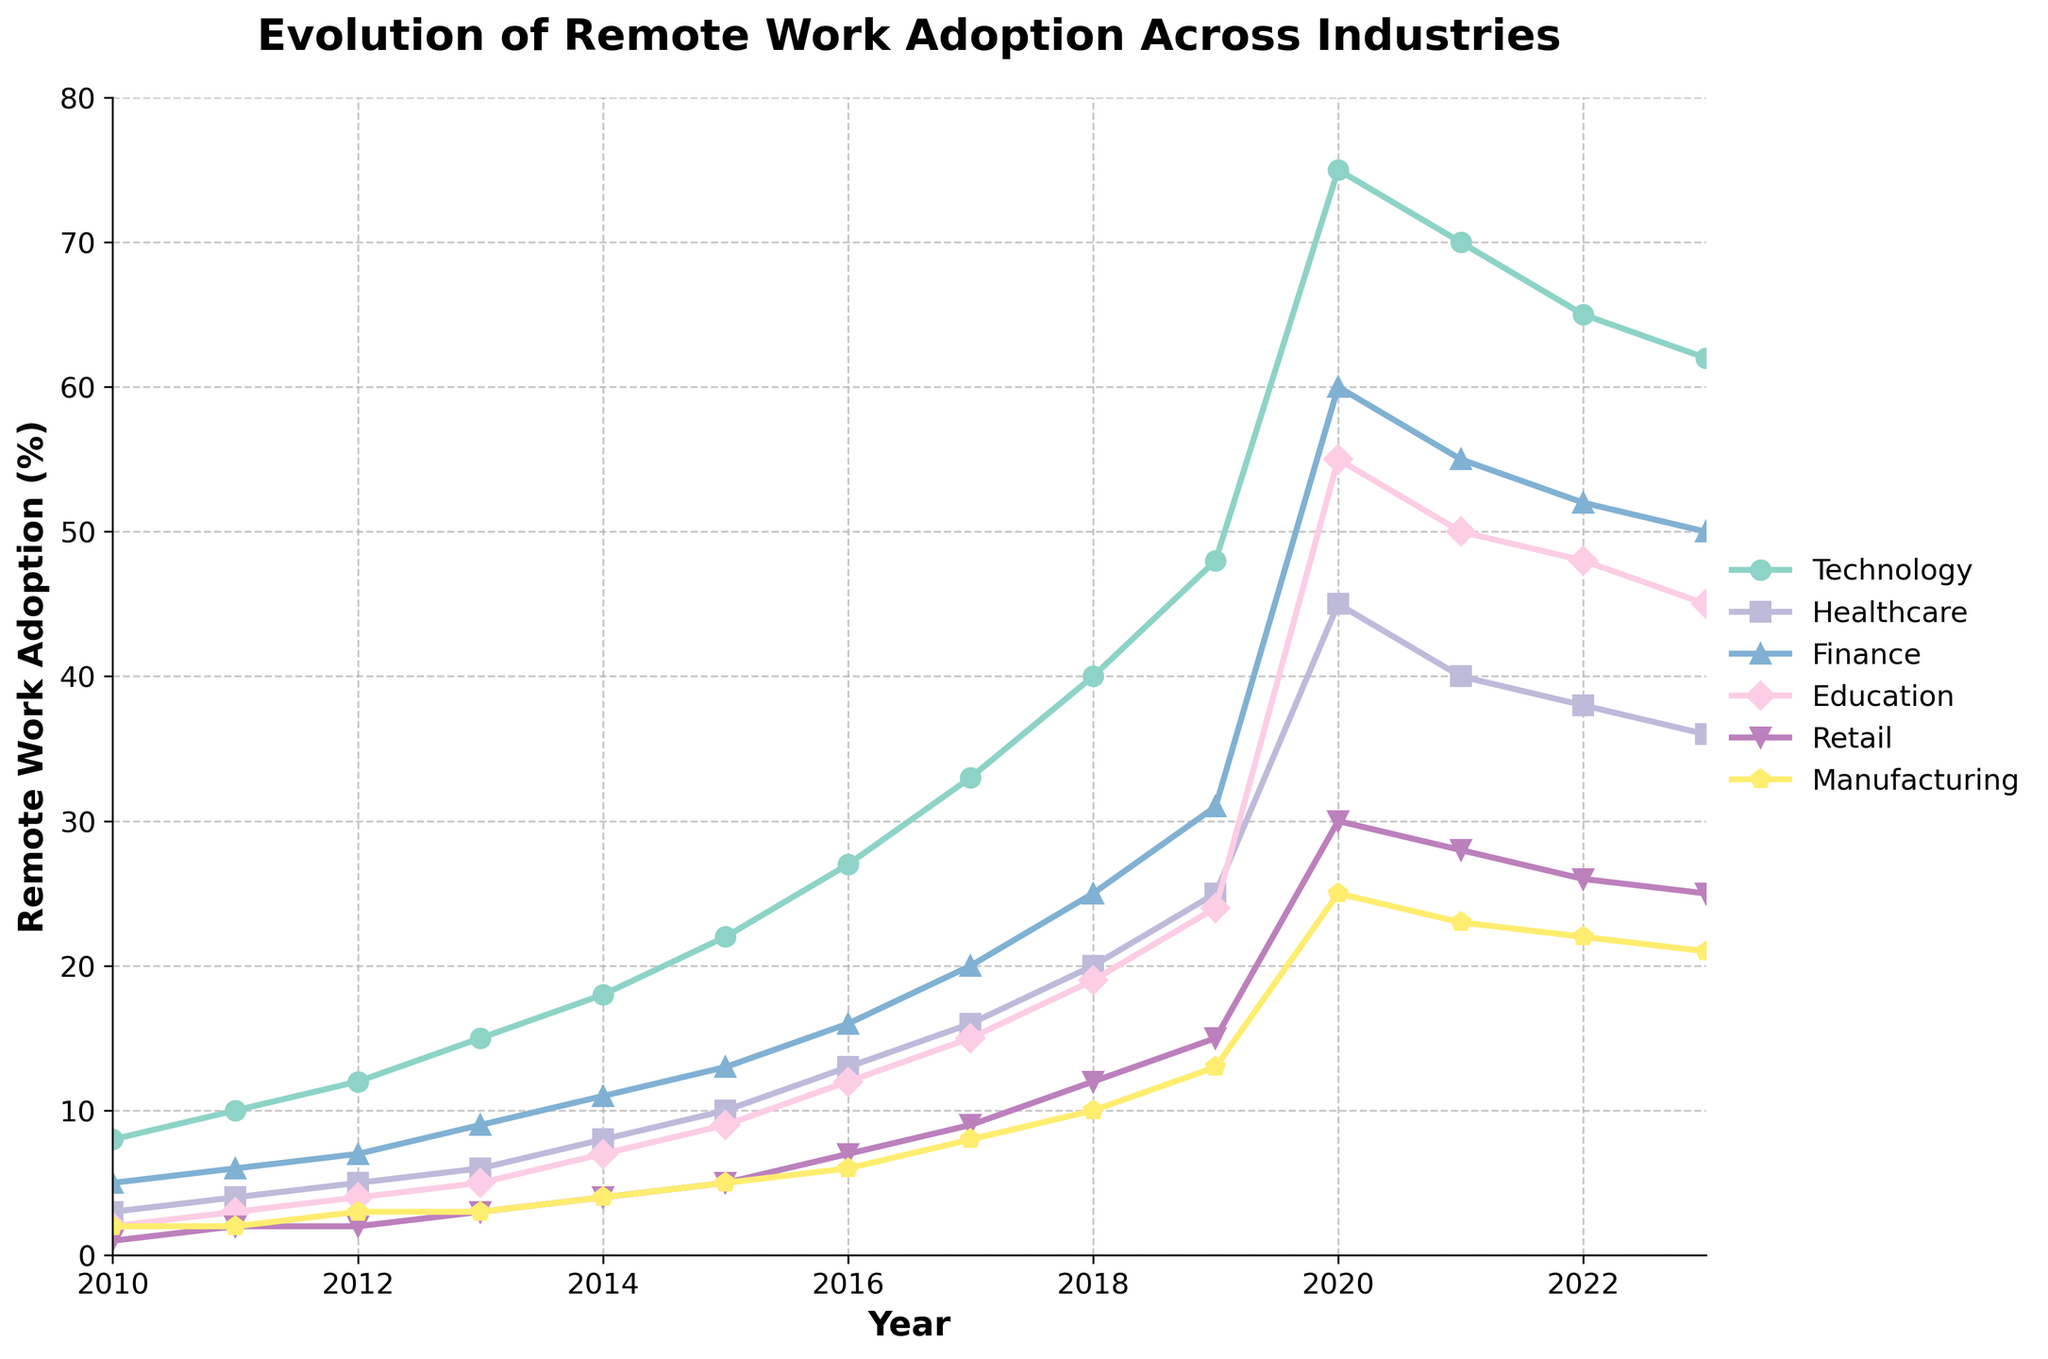Which industry saw the highest peak of remote work adoption? To determine the highest peak, look for the highest point on the chart for each industry. The Technology sector peaks in 2020 with a value of 75%.
Answer: Technology Which industry had the slowest increase in remote work adoption from 2010 to 2023? Compare the starting and ending values for each industry. Manufacturing starts at 2% in 2010 and ends at 21% in 2023, which is the slowest increase.
Answer: Manufacturing During which year did the Education sector see the largest year-over-year increase in remote work adoption? Examine the year-over-year numbers for Education, specifically looking for the largest jump. The largest increase is from 2019 (24%) to 2020 (55%), which is 31%.
Answer: 2020 How does the 2023 value for the Finance industry compare to its 2010 value? Subtract the 2010 value (5%) from the 2023 value (50%) for Finance. The difference is 50% - 5% = 45%.
Answer: 45% Which industry experienced a decline in remote work adoption after 2020? Compare the values for each industry from 2020 to 2023. Both Technology (75% to 62%) and Healthcare (45% to 36%) experienced declines.
Answer: Technology and Healthcare What is the average remote work adoption in the Retail industry from 2010 to 2023? Sum the values for Retail and divide by the number of years: (2+3+4+5+7+9+12+15+19+24+55+50+48+45) / 14 ≈ 21.
Answer: ~21 In what year did Finance surpass Education in remote work adoption? Track the lines for Finance and Education. Finance first surpasses Education after 2013 and firmly in 2014 with Finance at 13% and Education at 11%.
Answer: 2014 Which year did all industries see the highest total remote work adoption combined? Sum the remote work adoption values for all industries for each year and find the highest sum. The sum for 2020 is the highest: 75+45+60+55+30+25 = 290.
Answer: 2020 Compare the remote work adoption growth trend in Healthcare and Manufacturing from 2010 to 2023. Look at the growth curves of Healthcare and Manufacturing. Healthcare consistently grows faster than Manufacturing, starting at 3% and ending at 36%, while Manufacturing grows from 2% to 21%.
Answer: Healthcare grows faster 